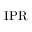<formula> <loc_0><loc_0><loc_500><loc_500>{ I P R }</formula> 